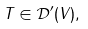Convert formula to latex. <formula><loc_0><loc_0><loc_500><loc_500>T \in { \mathcal { D } } ^ { \prime } ( V ) ,</formula> 